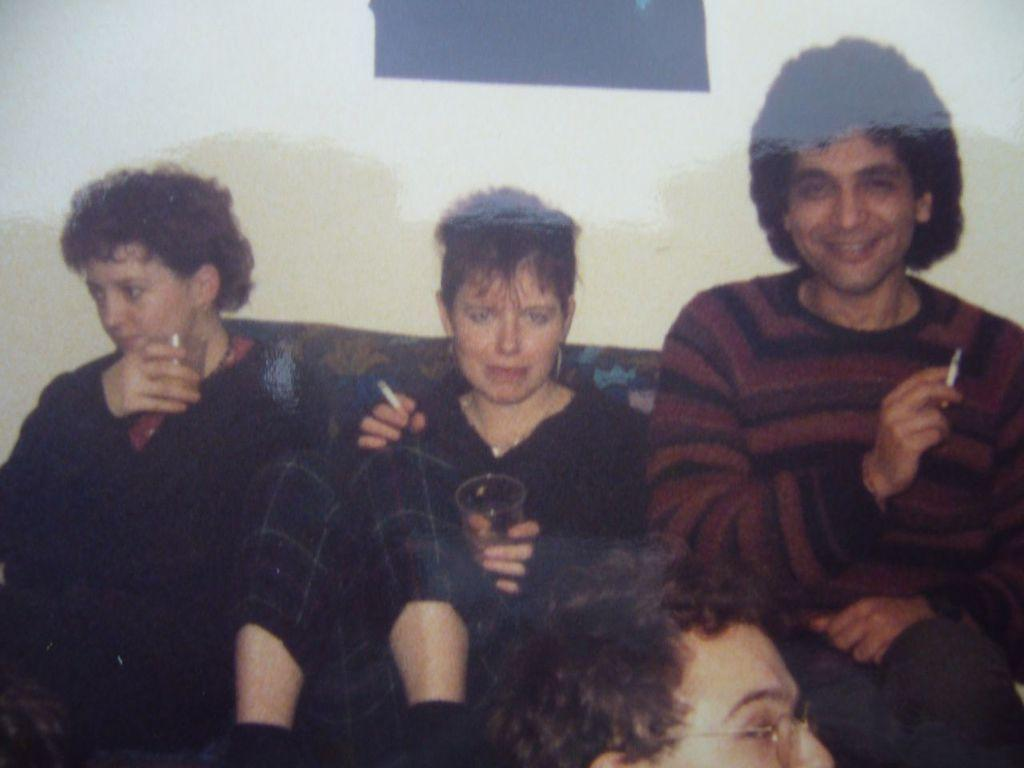How many people are sitting on the sofa set in the image? There are three persons sitting on a sofa set in the image. What is happening at the bottom of the image? There is another person at the bottom of the image. What can be seen in the background of the image? There is a wall visible in the image. What are the persons in the middle of the image holding? There are persons holding an object in the middle of the image. How many frogs are sitting on the sofa set in the image? There are no frogs present in the image; it features three persons sitting on a sofa set. What type of butter is being used by the persons in the image? There is no butter present in the image; it features persons holding an object, but no butter is mentioned or visible. 